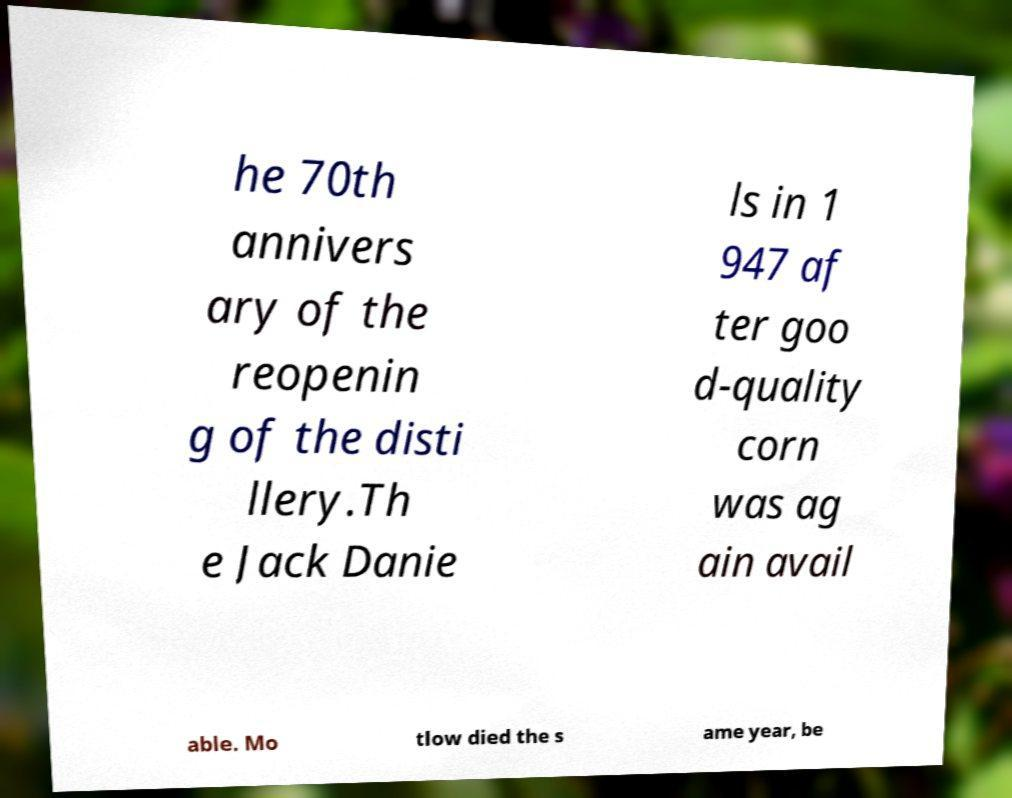Please read and relay the text visible in this image. What does it say? he 70th annivers ary of the reopenin g of the disti llery.Th e Jack Danie ls in 1 947 af ter goo d-quality corn was ag ain avail able. Mo tlow died the s ame year, be 